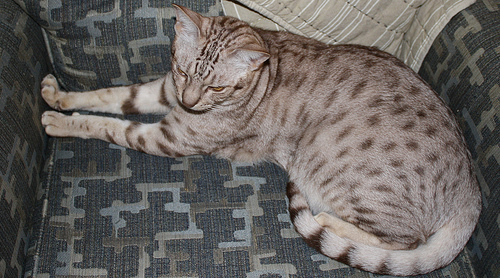<image>
Is the chair under the cat? Yes. The chair is positioned underneath the cat, with the cat above it in the vertical space. Where is the sofa in relation to the cat? Is it in the cat? No. The sofa is not contained within the cat. These objects have a different spatial relationship. 